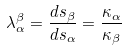Convert formula to latex. <formula><loc_0><loc_0><loc_500><loc_500>\lambda ^ { \beta } _ { \alpha } = \frac { d s _ { \beta } } { d s _ { \alpha } } = \frac { \kappa _ { \alpha } } { \kappa _ { \beta } }</formula> 